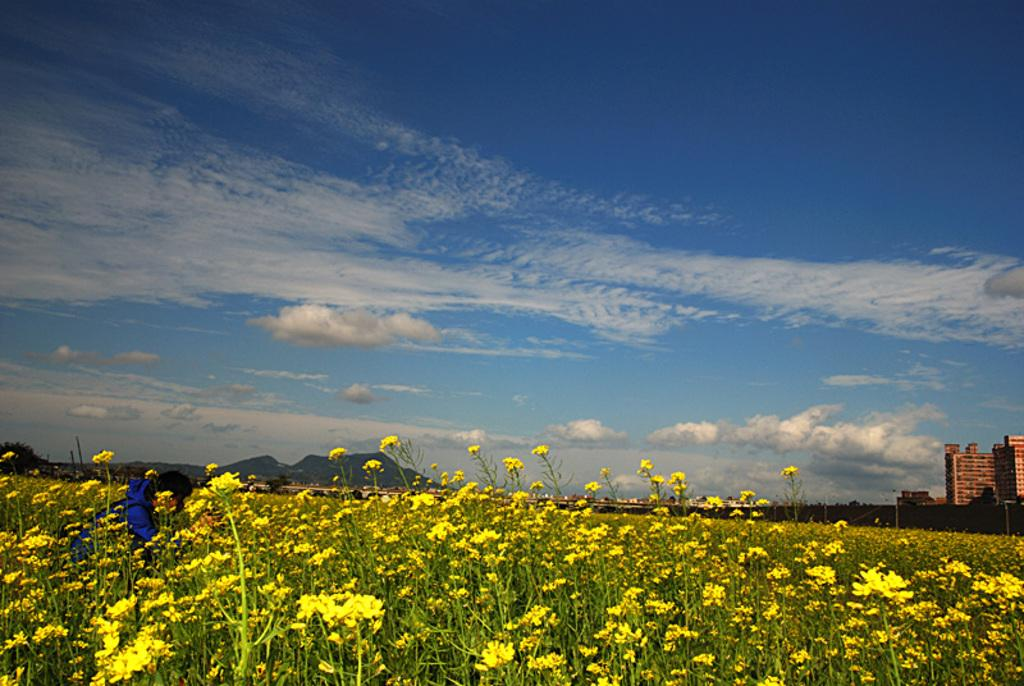What type of flowers can be seen in the image? There are yellow flowers in the image. What can be seen in the distance behind the flowers? There are mountains and buildings in the background of the image. What is visible in the sky at the top of the image? There are clouds visible in the sky at the top of the image. How many bears can be seen sneezing in the image? There are no bears present in the image, and therefore no sneezing can be observed. 